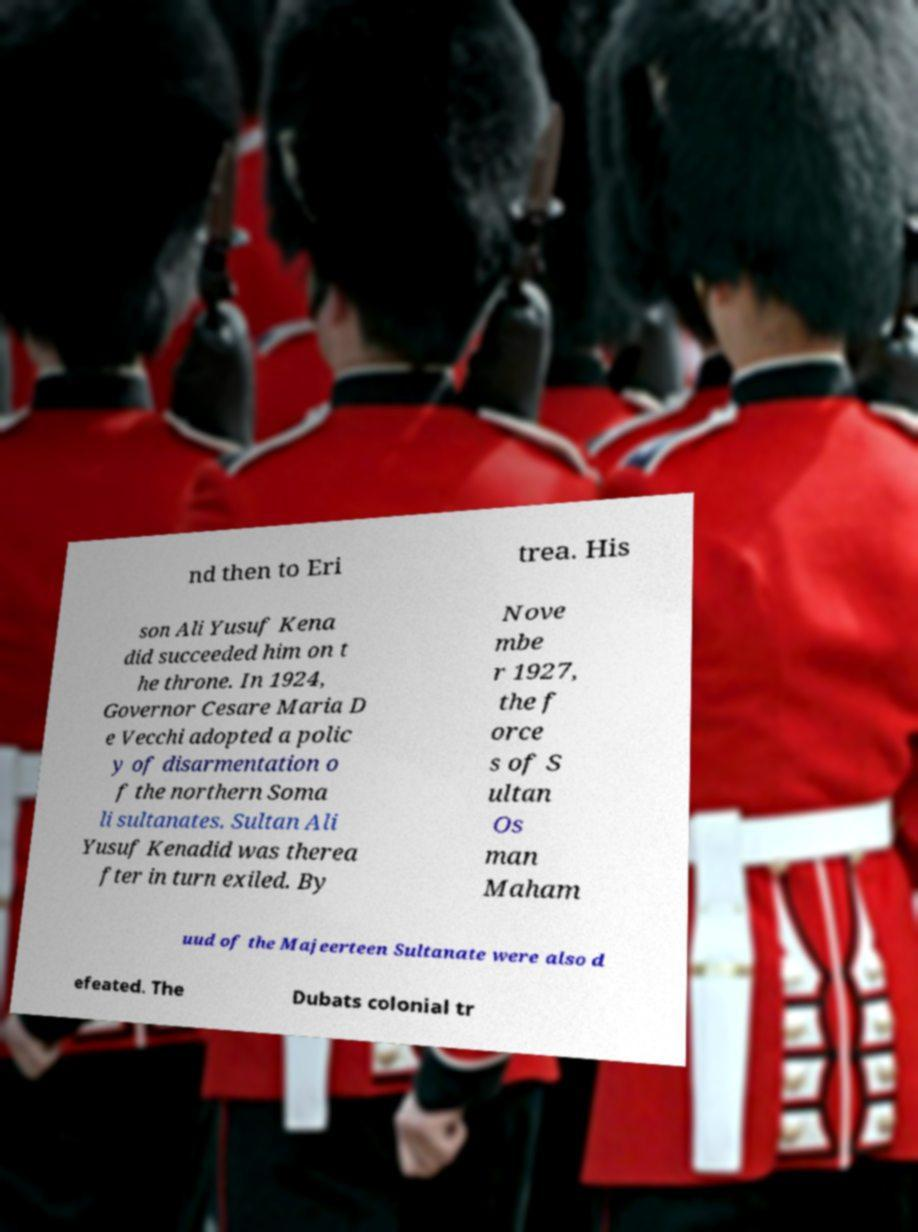Please read and relay the text visible in this image. What does it say? nd then to Eri trea. His son Ali Yusuf Kena did succeeded him on t he throne. In 1924, Governor Cesare Maria D e Vecchi adopted a polic y of disarmentation o f the northern Soma li sultanates. Sultan Ali Yusuf Kenadid was therea fter in turn exiled. By Nove mbe r 1927, the f orce s of S ultan Os man Maham uud of the Majeerteen Sultanate were also d efeated. The Dubats colonial tr 